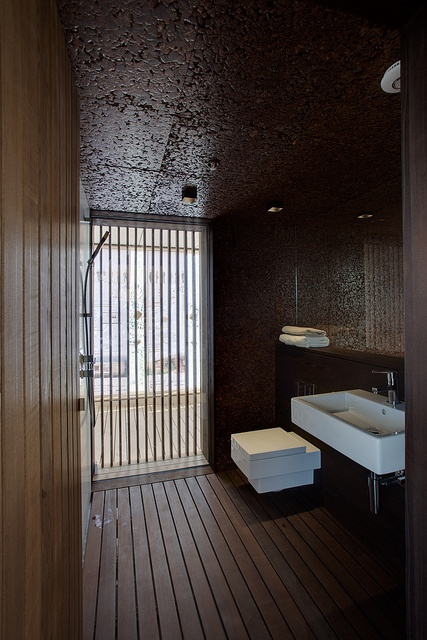Describe the objects in this image and their specific colors. I can see sink in black, darkgray, and gray tones and toilet in black, gray, and tan tones in this image. 